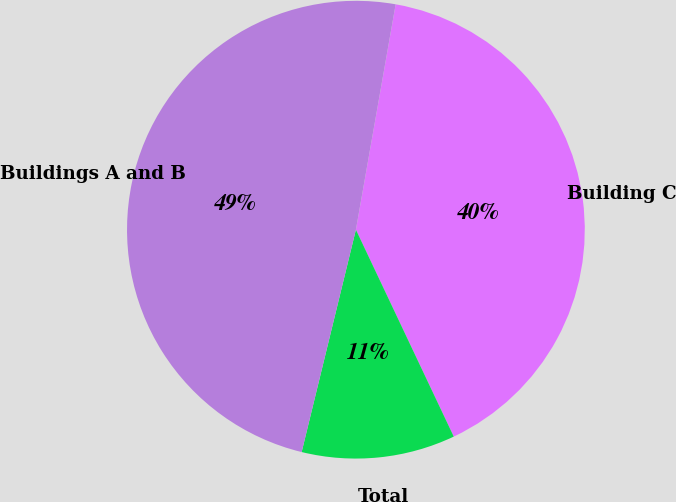Convert chart to OTSL. <chart><loc_0><loc_0><loc_500><loc_500><pie_chart><fcel>Building C<fcel>Total<fcel>Buildings A and B<nl><fcel>40.19%<fcel>10.84%<fcel>48.97%<nl></chart> 